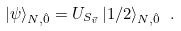<formula> <loc_0><loc_0><loc_500><loc_500>| \psi \rangle _ { N , \hat { 0 } } = U _ { S _ { \vec { v } } } \, | 1 / 2 \rangle _ { N , \hat { 0 } } \ .</formula> 